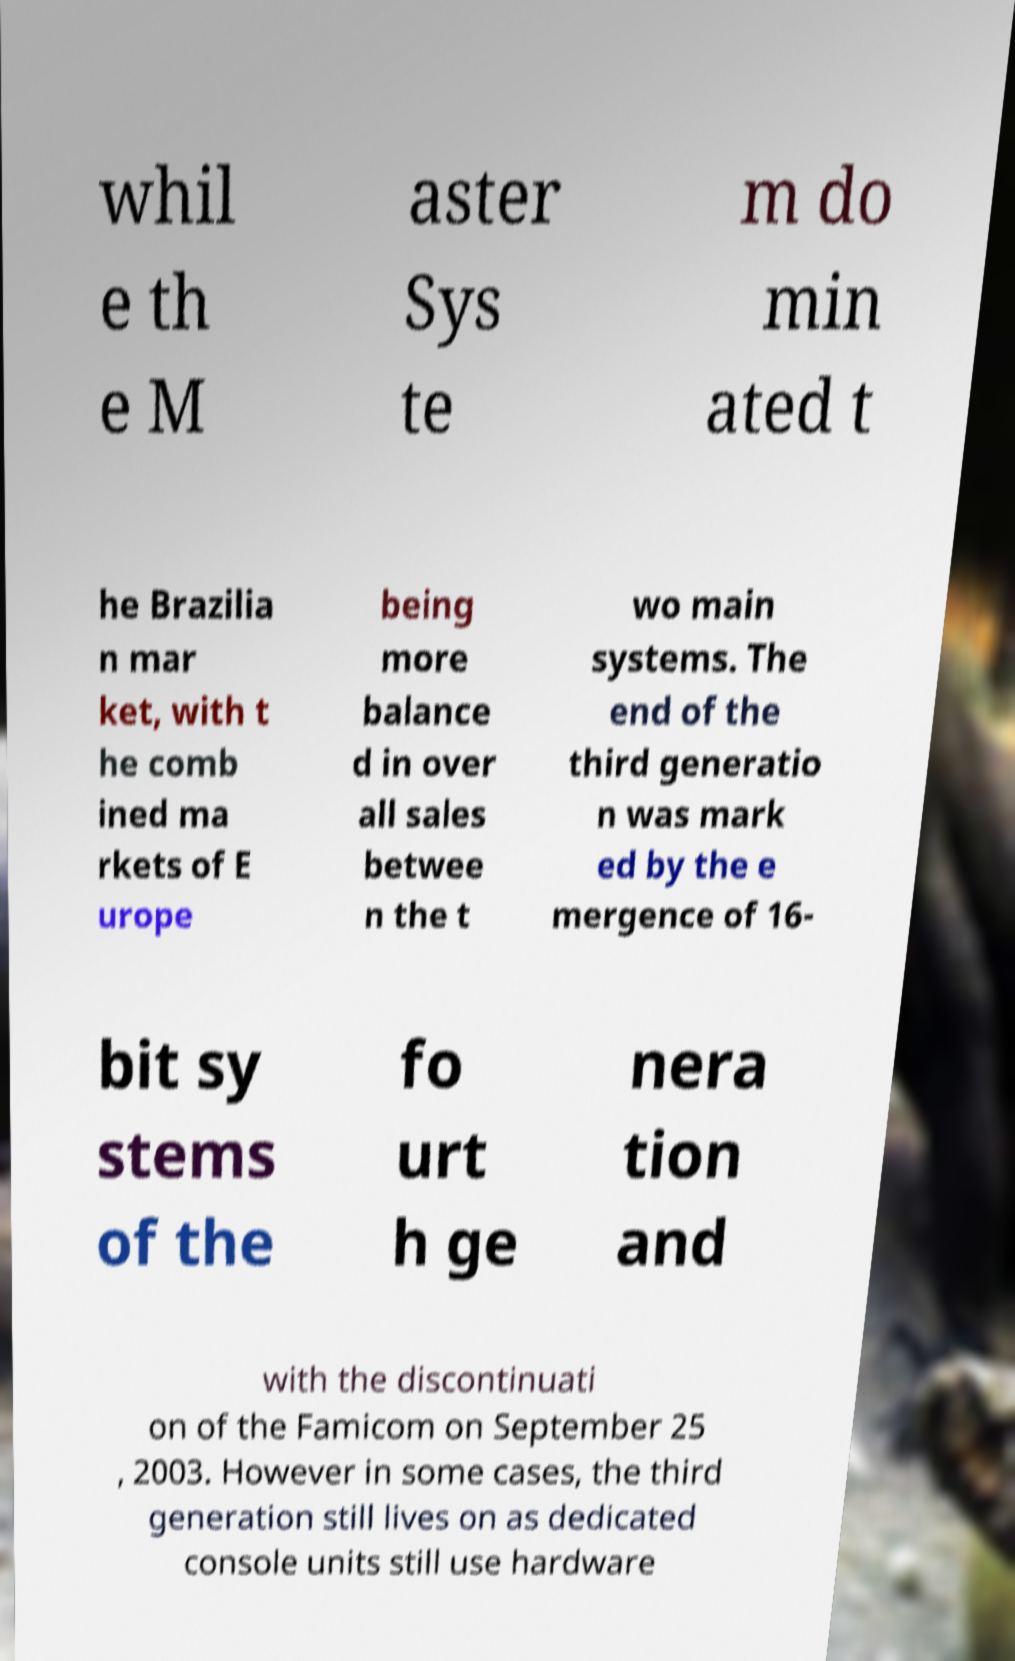Could you assist in decoding the text presented in this image and type it out clearly? whil e th e M aster Sys te m do min ated t he Brazilia n mar ket, with t he comb ined ma rkets of E urope being more balance d in over all sales betwee n the t wo main systems. The end of the third generatio n was mark ed by the e mergence of 16- bit sy stems of the fo urt h ge nera tion and with the discontinuati on of the Famicom on September 25 , 2003. However in some cases, the third generation still lives on as dedicated console units still use hardware 